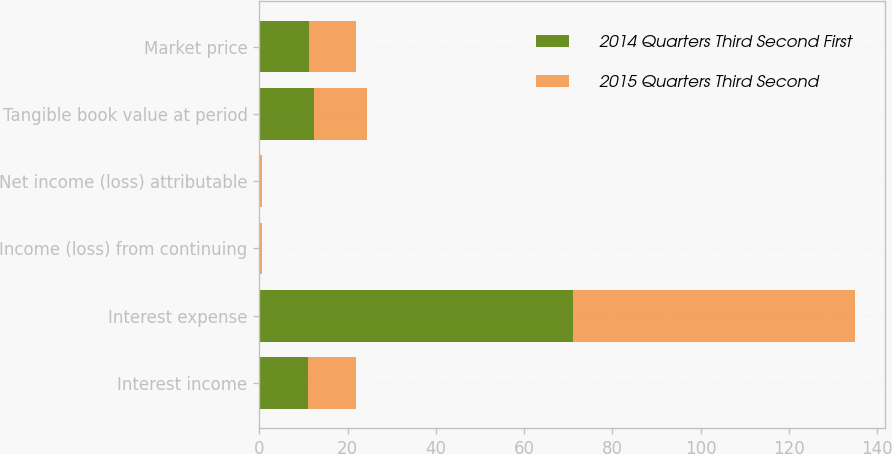Convert chart to OTSL. <chart><loc_0><loc_0><loc_500><loc_500><stacked_bar_chart><ecel><fcel>Interest income<fcel>Interest expense<fcel>Income (loss) from continuing<fcel>Net income (loss) attributable<fcel>Tangible book value at period<fcel>Market price<nl><fcel>2014 Quarters Third Second First<fcel>10.935<fcel>71<fcel>0.27<fcel>0.27<fcel>12.51<fcel>11.22<nl><fcel>2015 Quarters Third Second<fcel>10.935<fcel>64<fcel>0.28<fcel>0.29<fcel>11.91<fcel>10.65<nl></chart> 